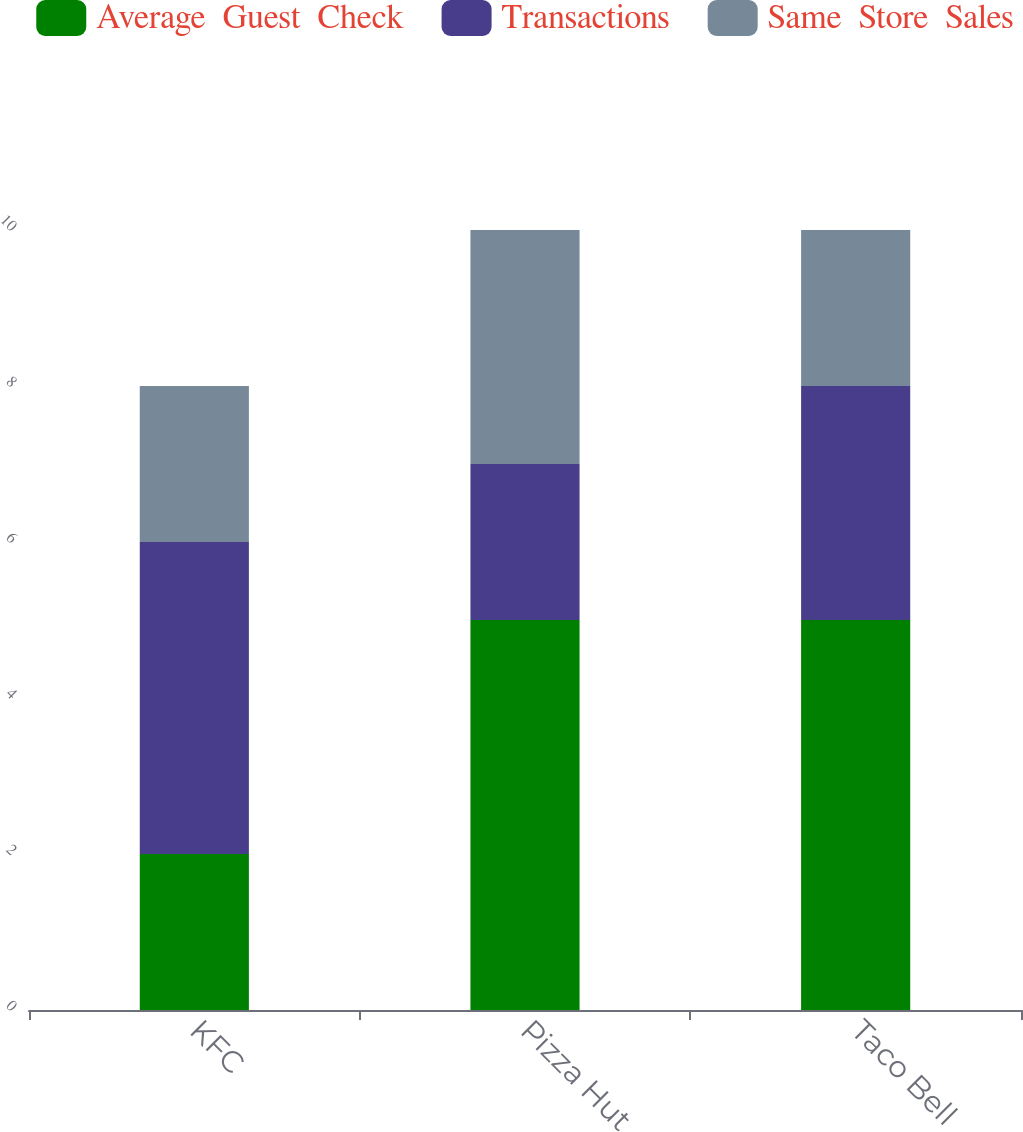<chart> <loc_0><loc_0><loc_500><loc_500><stacked_bar_chart><ecel><fcel>KFC<fcel>Pizza Hut<fcel>Taco Bell<nl><fcel>Average  Guest  Check<fcel>2<fcel>5<fcel>5<nl><fcel>Transactions<fcel>4<fcel>2<fcel>3<nl><fcel>Same  Store  Sales<fcel>2<fcel>3<fcel>2<nl></chart> 